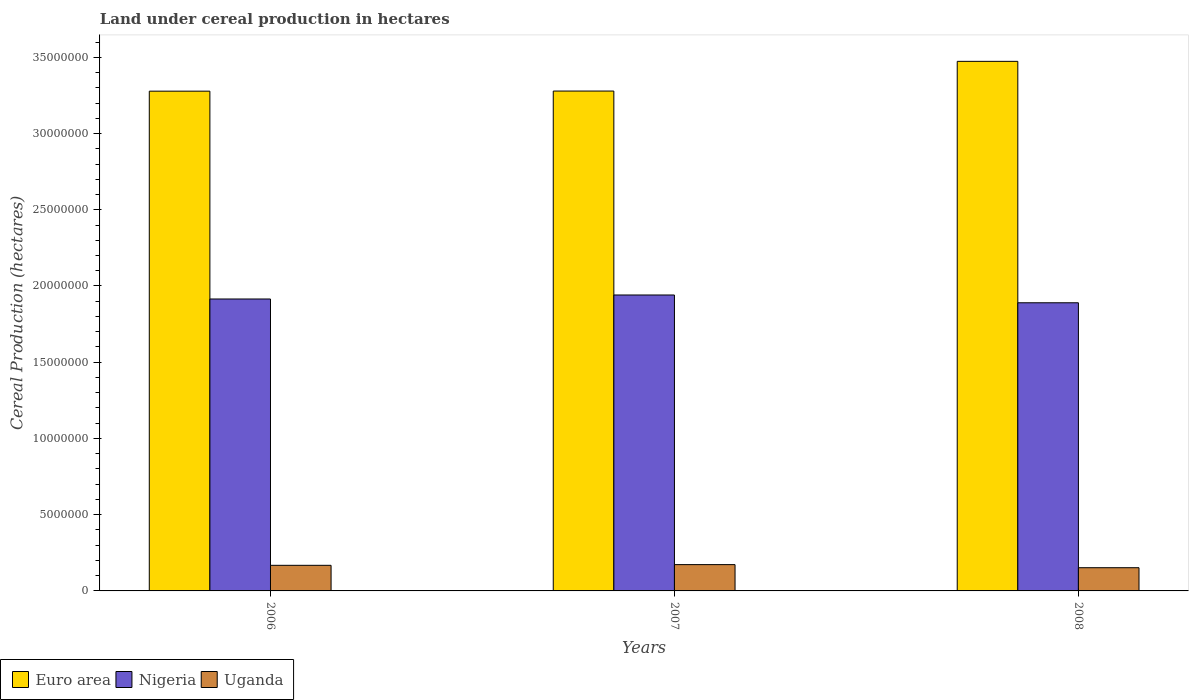How many different coloured bars are there?
Provide a short and direct response. 3. Are the number of bars on each tick of the X-axis equal?
Provide a short and direct response. Yes. How many bars are there on the 3rd tick from the right?
Your answer should be very brief. 3. What is the label of the 3rd group of bars from the left?
Offer a very short reply. 2008. What is the land under cereal production in Nigeria in 2007?
Make the answer very short. 1.94e+07. Across all years, what is the maximum land under cereal production in Euro area?
Give a very brief answer. 3.47e+07. Across all years, what is the minimum land under cereal production in Euro area?
Keep it short and to the point. 3.28e+07. In which year was the land under cereal production in Nigeria maximum?
Keep it short and to the point. 2007. What is the total land under cereal production in Uganda in the graph?
Offer a very short reply. 4.93e+06. What is the difference between the land under cereal production in Uganda in 2006 and that in 2007?
Ensure brevity in your answer.  -4.60e+04. What is the difference between the land under cereal production in Nigeria in 2008 and the land under cereal production in Uganda in 2007?
Make the answer very short. 1.72e+07. What is the average land under cereal production in Nigeria per year?
Offer a terse response. 1.92e+07. In the year 2006, what is the difference between the land under cereal production in Euro area and land under cereal production in Uganda?
Offer a terse response. 3.11e+07. In how many years, is the land under cereal production in Euro area greater than 13000000 hectares?
Keep it short and to the point. 3. What is the ratio of the land under cereal production in Uganda in 2006 to that in 2008?
Provide a short and direct response. 1.1. What is the difference between the highest and the second highest land under cereal production in Euro area?
Offer a terse response. 1.95e+06. What is the difference between the highest and the lowest land under cereal production in Euro area?
Provide a short and direct response. 1.95e+06. Is the sum of the land under cereal production in Uganda in 2007 and 2008 greater than the maximum land under cereal production in Nigeria across all years?
Make the answer very short. No. What does the 3rd bar from the left in 2007 represents?
Your response must be concise. Uganda. What does the 1st bar from the right in 2008 represents?
Your answer should be very brief. Uganda. How many years are there in the graph?
Your answer should be very brief. 3. Does the graph contain grids?
Provide a succinct answer. No. Where does the legend appear in the graph?
Offer a terse response. Bottom left. How many legend labels are there?
Give a very brief answer. 3. What is the title of the graph?
Provide a succinct answer. Land under cereal production in hectares. Does "France" appear as one of the legend labels in the graph?
Your answer should be very brief. No. What is the label or title of the Y-axis?
Provide a short and direct response. Cereal Production (hectares). What is the Cereal Production (hectares) of Euro area in 2006?
Ensure brevity in your answer.  3.28e+07. What is the Cereal Production (hectares) of Nigeria in 2006?
Provide a succinct answer. 1.91e+07. What is the Cereal Production (hectares) in Uganda in 2006?
Your answer should be very brief. 1.68e+06. What is the Cereal Production (hectares) in Euro area in 2007?
Offer a terse response. 3.28e+07. What is the Cereal Production (hectares) of Nigeria in 2007?
Offer a very short reply. 1.94e+07. What is the Cereal Production (hectares) of Uganda in 2007?
Your response must be concise. 1.72e+06. What is the Cereal Production (hectares) in Euro area in 2008?
Offer a very short reply. 3.47e+07. What is the Cereal Production (hectares) of Nigeria in 2008?
Provide a succinct answer. 1.89e+07. What is the Cereal Production (hectares) in Uganda in 2008?
Keep it short and to the point. 1.52e+06. Across all years, what is the maximum Cereal Production (hectares) in Euro area?
Your answer should be compact. 3.47e+07. Across all years, what is the maximum Cereal Production (hectares) in Nigeria?
Your answer should be very brief. 1.94e+07. Across all years, what is the maximum Cereal Production (hectares) of Uganda?
Ensure brevity in your answer.  1.72e+06. Across all years, what is the minimum Cereal Production (hectares) in Euro area?
Provide a succinct answer. 3.28e+07. Across all years, what is the minimum Cereal Production (hectares) of Nigeria?
Your response must be concise. 1.89e+07. Across all years, what is the minimum Cereal Production (hectares) in Uganda?
Your response must be concise. 1.52e+06. What is the total Cereal Production (hectares) in Euro area in the graph?
Offer a terse response. 1.00e+08. What is the total Cereal Production (hectares) of Nigeria in the graph?
Give a very brief answer. 5.75e+07. What is the total Cereal Production (hectares) in Uganda in the graph?
Your answer should be compact. 4.93e+06. What is the difference between the Cereal Production (hectares) of Euro area in 2006 and that in 2007?
Provide a succinct answer. -6362. What is the difference between the Cereal Production (hectares) of Nigeria in 2006 and that in 2007?
Your response must be concise. -2.63e+05. What is the difference between the Cereal Production (hectares) of Uganda in 2006 and that in 2007?
Your response must be concise. -4.60e+04. What is the difference between the Cereal Production (hectares) in Euro area in 2006 and that in 2008?
Ensure brevity in your answer.  -1.95e+06. What is the difference between the Cereal Production (hectares) of Nigeria in 2006 and that in 2008?
Ensure brevity in your answer.  2.48e+05. What is the difference between the Cereal Production (hectares) of Uganda in 2006 and that in 2008?
Ensure brevity in your answer.  1.57e+05. What is the difference between the Cereal Production (hectares) of Euro area in 2007 and that in 2008?
Ensure brevity in your answer.  -1.95e+06. What is the difference between the Cereal Production (hectares) in Nigeria in 2007 and that in 2008?
Ensure brevity in your answer.  5.11e+05. What is the difference between the Cereal Production (hectares) of Uganda in 2007 and that in 2008?
Your answer should be compact. 2.03e+05. What is the difference between the Cereal Production (hectares) in Euro area in 2006 and the Cereal Production (hectares) in Nigeria in 2007?
Make the answer very short. 1.34e+07. What is the difference between the Cereal Production (hectares) of Euro area in 2006 and the Cereal Production (hectares) of Uganda in 2007?
Make the answer very short. 3.11e+07. What is the difference between the Cereal Production (hectares) in Nigeria in 2006 and the Cereal Production (hectares) in Uganda in 2007?
Make the answer very short. 1.74e+07. What is the difference between the Cereal Production (hectares) of Euro area in 2006 and the Cereal Production (hectares) of Nigeria in 2008?
Provide a short and direct response. 1.39e+07. What is the difference between the Cereal Production (hectares) of Euro area in 2006 and the Cereal Production (hectares) of Uganda in 2008?
Provide a short and direct response. 3.13e+07. What is the difference between the Cereal Production (hectares) in Nigeria in 2006 and the Cereal Production (hectares) in Uganda in 2008?
Your answer should be very brief. 1.76e+07. What is the difference between the Cereal Production (hectares) of Euro area in 2007 and the Cereal Production (hectares) of Nigeria in 2008?
Provide a short and direct response. 1.39e+07. What is the difference between the Cereal Production (hectares) in Euro area in 2007 and the Cereal Production (hectares) in Uganda in 2008?
Keep it short and to the point. 3.13e+07. What is the difference between the Cereal Production (hectares) of Nigeria in 2007 and the Cereal Production (hectares) of Uganda in 2008?
Ensure brevity in your answer.  1.79e+07. What is the average Cereal Production (hectares) of Euro area per year?
Provide a succinct answer. 3.34e+07. What is the average Cereal Production (hectares) of Nigeria per year?
Your answer should be compact. 1.92e+07. What is the average Cereal Production (hectares) in Uganda per year?
Give a very brief answer. 1.64e+06. In the year 2006, what is the difference between the Cereal Production (hectares) of Euro area and Cereal Production (hectares) of Nigeria?
Give a very brief answer. 1.36e+07. In the year 2006, what is the difference between the Cereal Production (hectares) in Euro area and Cereal Production (hectares) in Uganda?
Offer a terse response. 3.11e+07. In the year 2006, what is the difference between the Cereal Production (hectares) of Nigeria and Cereal Production (hectares) of Uganda?
Give a very brief answer. 1.75e+07. In the year 2007, what is the difference between the Cereal Production (hectares) of Euro area and Cereal Production (hectares) of Nigeria?
Offer a very short reply. 1.34e+07. In the year 2007, what is the difference between the Cereal Production (hectares) of Euro area and Cereal Production (hectares) of Uganda?
Offer a terse response. 3.11e+07. In the year 2007, what is the difference between the Cereal Production (hectares) in Nigeria and Cereal Production (hectares) in Uganda?
Your answer should be compact. 1.77e+07. In the year 2008, what is the difference between the Cereal Production (hectares) of Euro area and Cereal Production (hectares) of Nigeria?
Your answer should be compact. 1.58e+07. In the year 2008, what is the difference between the Cereal Production (hectares) of Euro area and Cereal Production (hectares) of Uganda?
Give a very brief answer. 3.32e+07. In the year 2008, what is the difference between the Cereal Production (hectares) in Nigeria and Cereal Production (hectares) in Uganda?
Your response must be concise. 1.74e+07. What is the ratio of the Cereal Production (hectares) in Euro area in 2006 to that in 2007?
Provide a succinct answer. 1. What is the ratio of the Cereal Production (hectares) of Nigeria in 2006 to that in 2007?
Give a very brief answer. 0.99. What is the ratio of the Cereal Production (hectares) of Uganda in 2006 to that in 2007?
Offer a terse response. 0.97. What is the ratio of the Cereal Production (hectares) in Euro area in 2006 to that in 2008?
Make the answer very short. 0.94. What is the ratio of the Cereal Production (hectares) in Nigeria in 2006 to that in 2008?
Offer a very short reply. 1.01. What is the ratio of the Cereal Production (hectares) of Uganda in 2006 to that in 2008?
Make the answer very short. 1.1. What is the ratio of the Cereal Production (hectares) of Euro area in 2007 to that in 2008?
Offer a very short reply. 0.94. What is the ratio of the Cereal Production (hectares) of Uganda in 2007 to that in 2008?
Give a very brief answer. 1.13. What is the difference between the highest and the second highest Cereal Production (hectares) in Euro area?
Offer a terse response. 1.95e+06. What is the difference between the highest and the second highest Cereal Production (hectares) in Nigeria?
Your answer should be compact. 2.63e+05. What is the difference between the highest and the second highest Cereal Production (hectares) of Uganda?
Your answer should be compact. 4.60e+04. What is the difference between the highest and the lowest Cereal Production (hectares) of Euro area?
Your response must be concise. 1.95e+06. What is the difference between the highest and the lowest Cereal Production (hectares) of Nigeria?
Keep it short and to the point. 5.11e+05. What is the difference between the highest and the lowest Cereal Production (hectares) in Uganda?
Keep it short and to the point. 2.03e+05. 